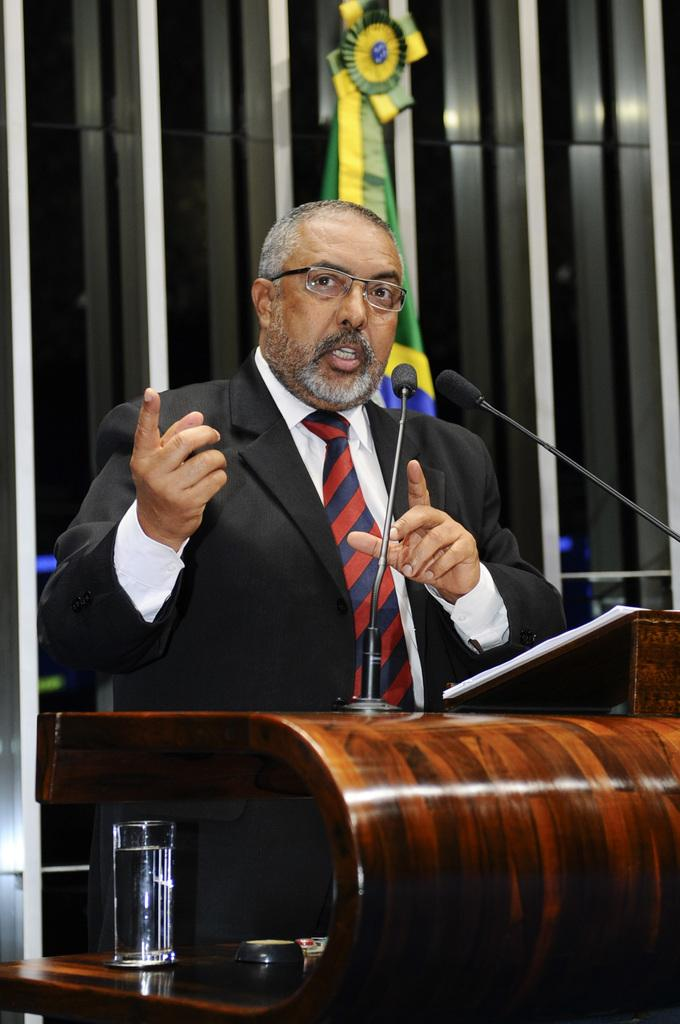What is the man in the image doing near the podium? The man is standing near a podium in the image. What is the man wearing? The man is wearing a black suit. What is in front of the man? There is a microphone in front of the man. What other object can be seen in the image? There is a glass in the image. What is visible at the back of the image? There is a flag at the back of the image. How does the man maintain complete silence in the image? The image does not provide information about the man's actions or the sound level in the scene. 